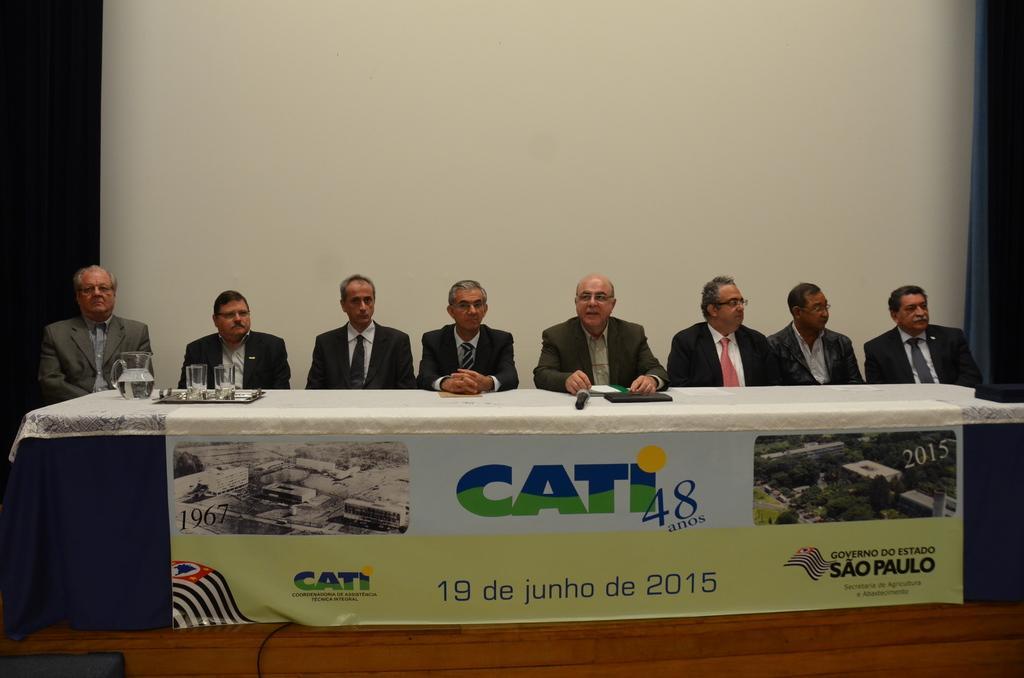Can you describe this image briefly? In this picture I can see group of people sitting , there is a jug, glasses on the tray , a mike and books on the table, and in the background there is a wall. 